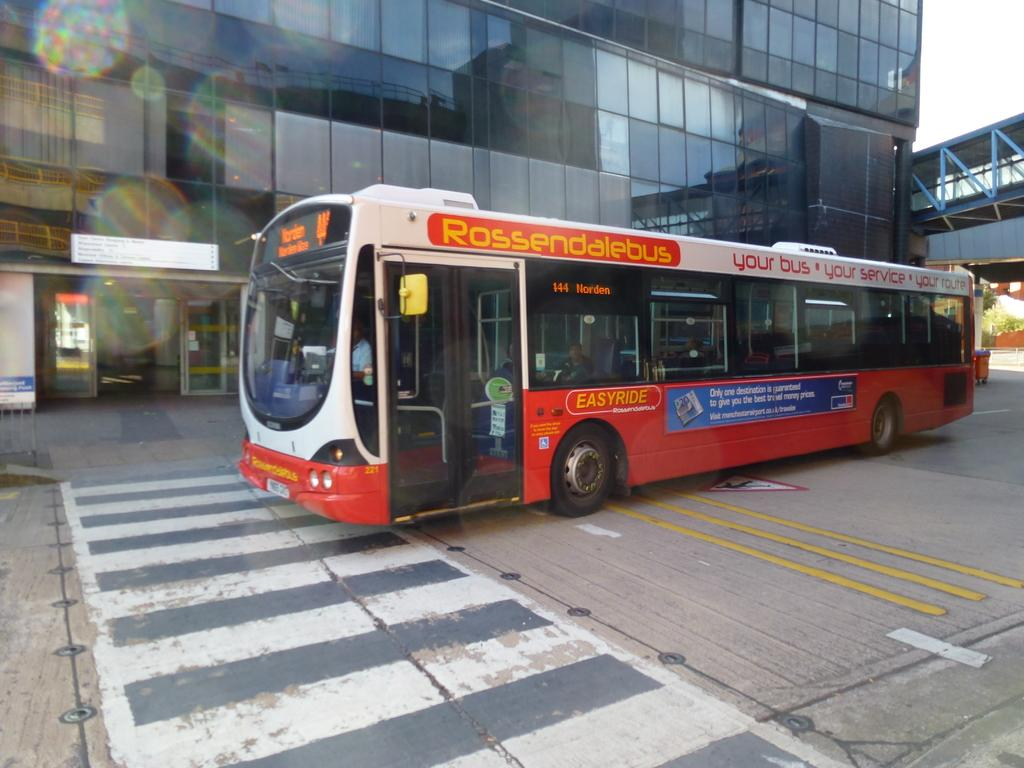<image>
Create a compact narrative representing the image presented. A Rossendalebus is on a city street near a crosswalk. 